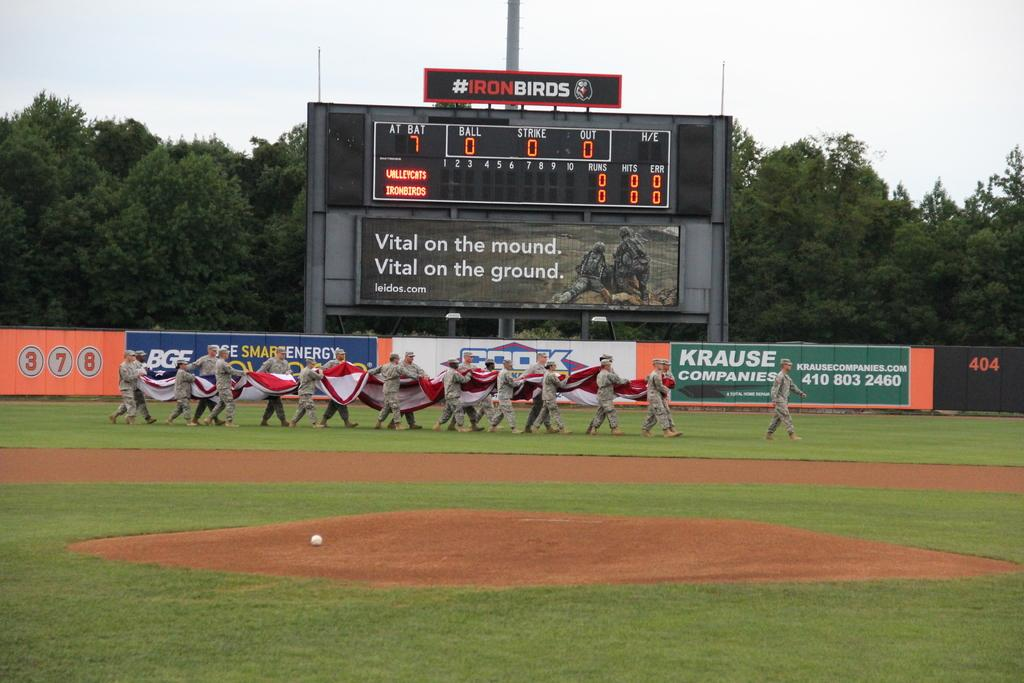<image>
Share a concise interpretation of the image provided. A baseball field where the Valleycats and Ironbirds will play 